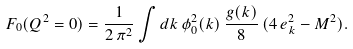<formula> <loc_0><loc_0><loc_500><loc_500>F _ { 0 } ( Q ^ { 2 } = 0 ) = \frac { 1 } { 2 \, \pi ^ { 2 } } \int d k \, \phi ^ { 2 } _ { 0 } ( k ) \, \frac { g ( k ) } { 8 } \, ( 4 \, e _ { k } ^ { 2 } - M ^ { 2 } ) .</formula> 